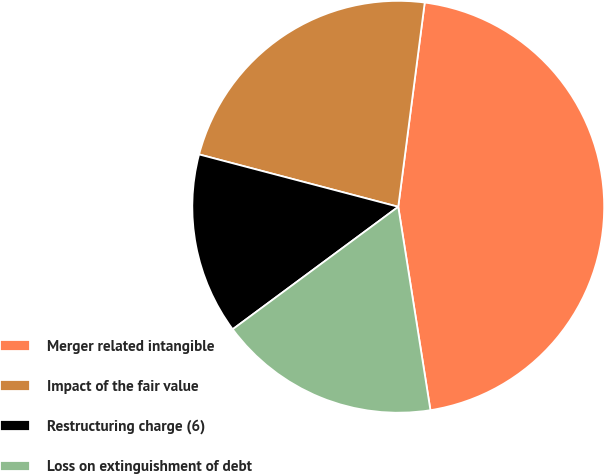<chart> <loc_0><loc_0><loc_500><loc_500><pie_chart><fcel>Merger related intangible<fcel>Impact of the fair value<fcel>Restructuring charge (6)<fcel>Loss on extinguishment of debt<nl><fcel>45.45%<fcel>22.96%<fcel>14.23%<fcel>17.36%<nl></chart> 